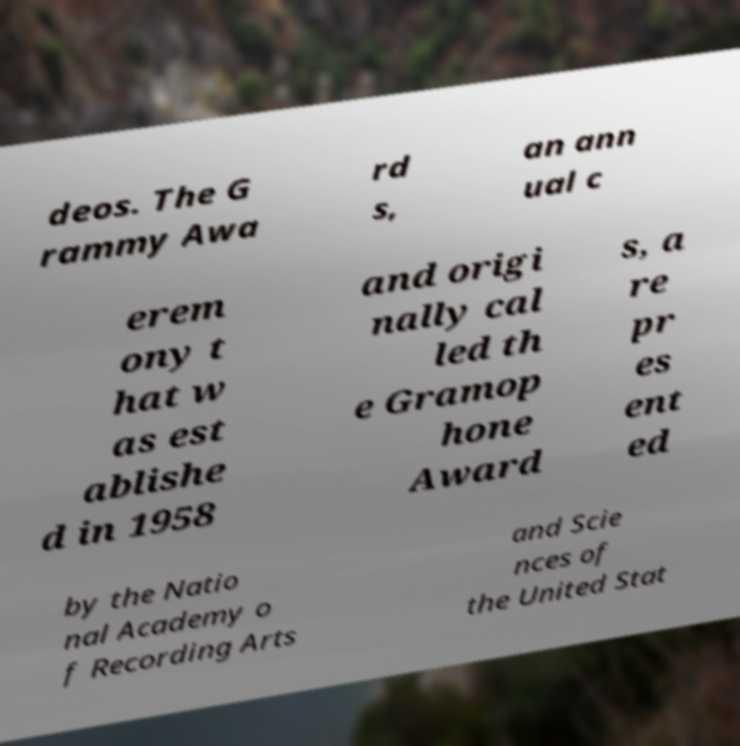I need the written content from this picture converted into text. Can you do that? deos. The G rammy Awa rd s, an ann ual c erem ony t hat w as est ablishe d in 1958 and origi nally cal led th e Gramop hone Award s, a re pr es ent ed by the Natio nal Academy o f Recording Arts and Scie nces of the United Stat 